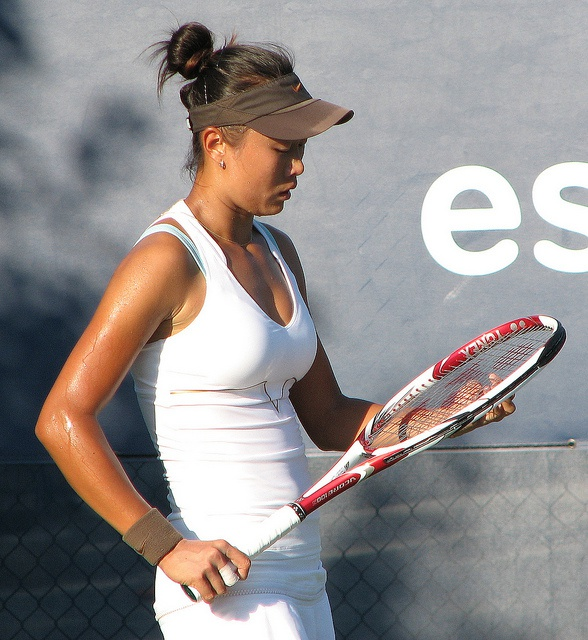Describe the objects in this image and their specific colors. I can see people in black, white, tan, and gray tones and tennis racket in black, white, darkgray, and gray tones in this image. 